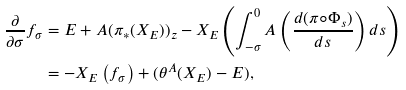<formula> <loc_0><loc_0><loc_500><loc_500>\frac { \partial } { \partial \sigma } f _ { \sigma } & = E + A ( \pi _ { \ast } ( X _ { E } ) ) _ { z } - X _ { E } \left ( \int _ { - \sigma } ^ { 0 } A \left ( \frac { d ( \pi \circ \Phi _ { s } ) } { d s } \right ) d s \right ) \\ & = - X _ { E } \left ( f _ { \sigma } \right ) + ( \theta ^ { A } ( X _ { E } ) - E ) ,</formula> 